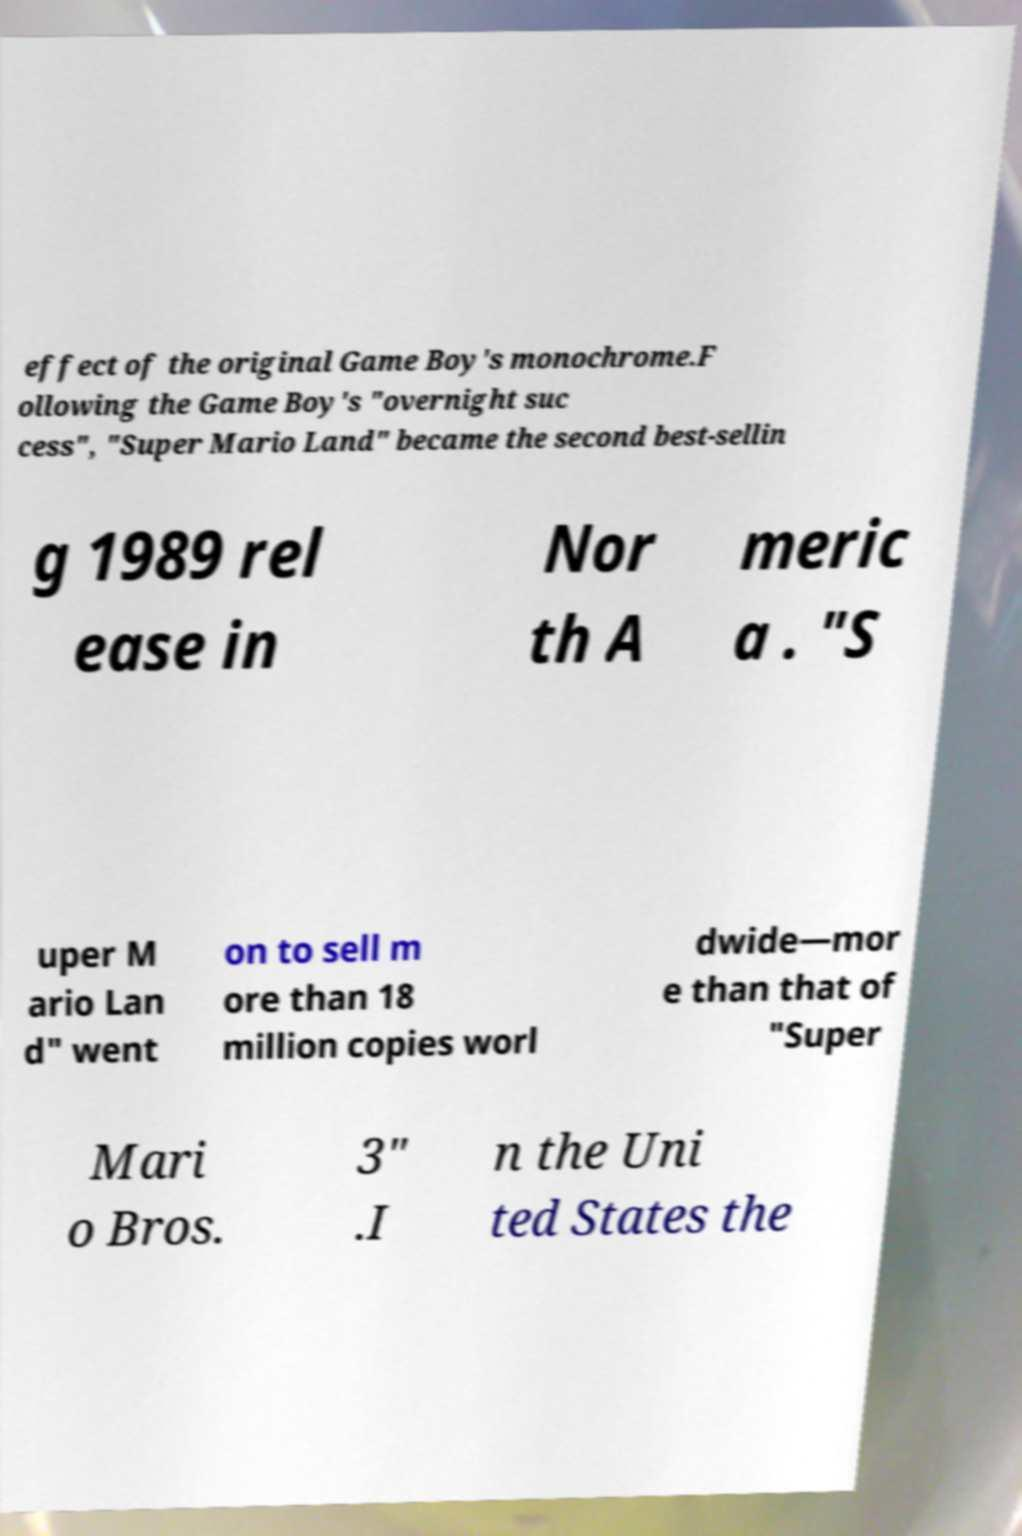Can you accurately transcribe the text from the provided image for me? effect of the original Game Boy's monochrome.F ollowing the Game Boy's "overnight suc cess", "Super Mario Land" became the second best-sellin g 1989 rel ease in Nor th A meric a . "S uper M ario Lan d" went on to sell m ore than 18 million copies worl dwide—mor e than that of "Super Mari o Bros. 3" .I n the Uni ted States the 